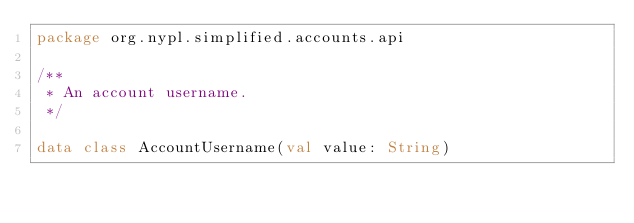<code> <loc_0><loc_0><loc_500><loc_500><_Kotlin_>package org.nypl.simplified.accounts.api

/**
 * An account username.
 */

data class AccountUsername(val value: String)
</code> 